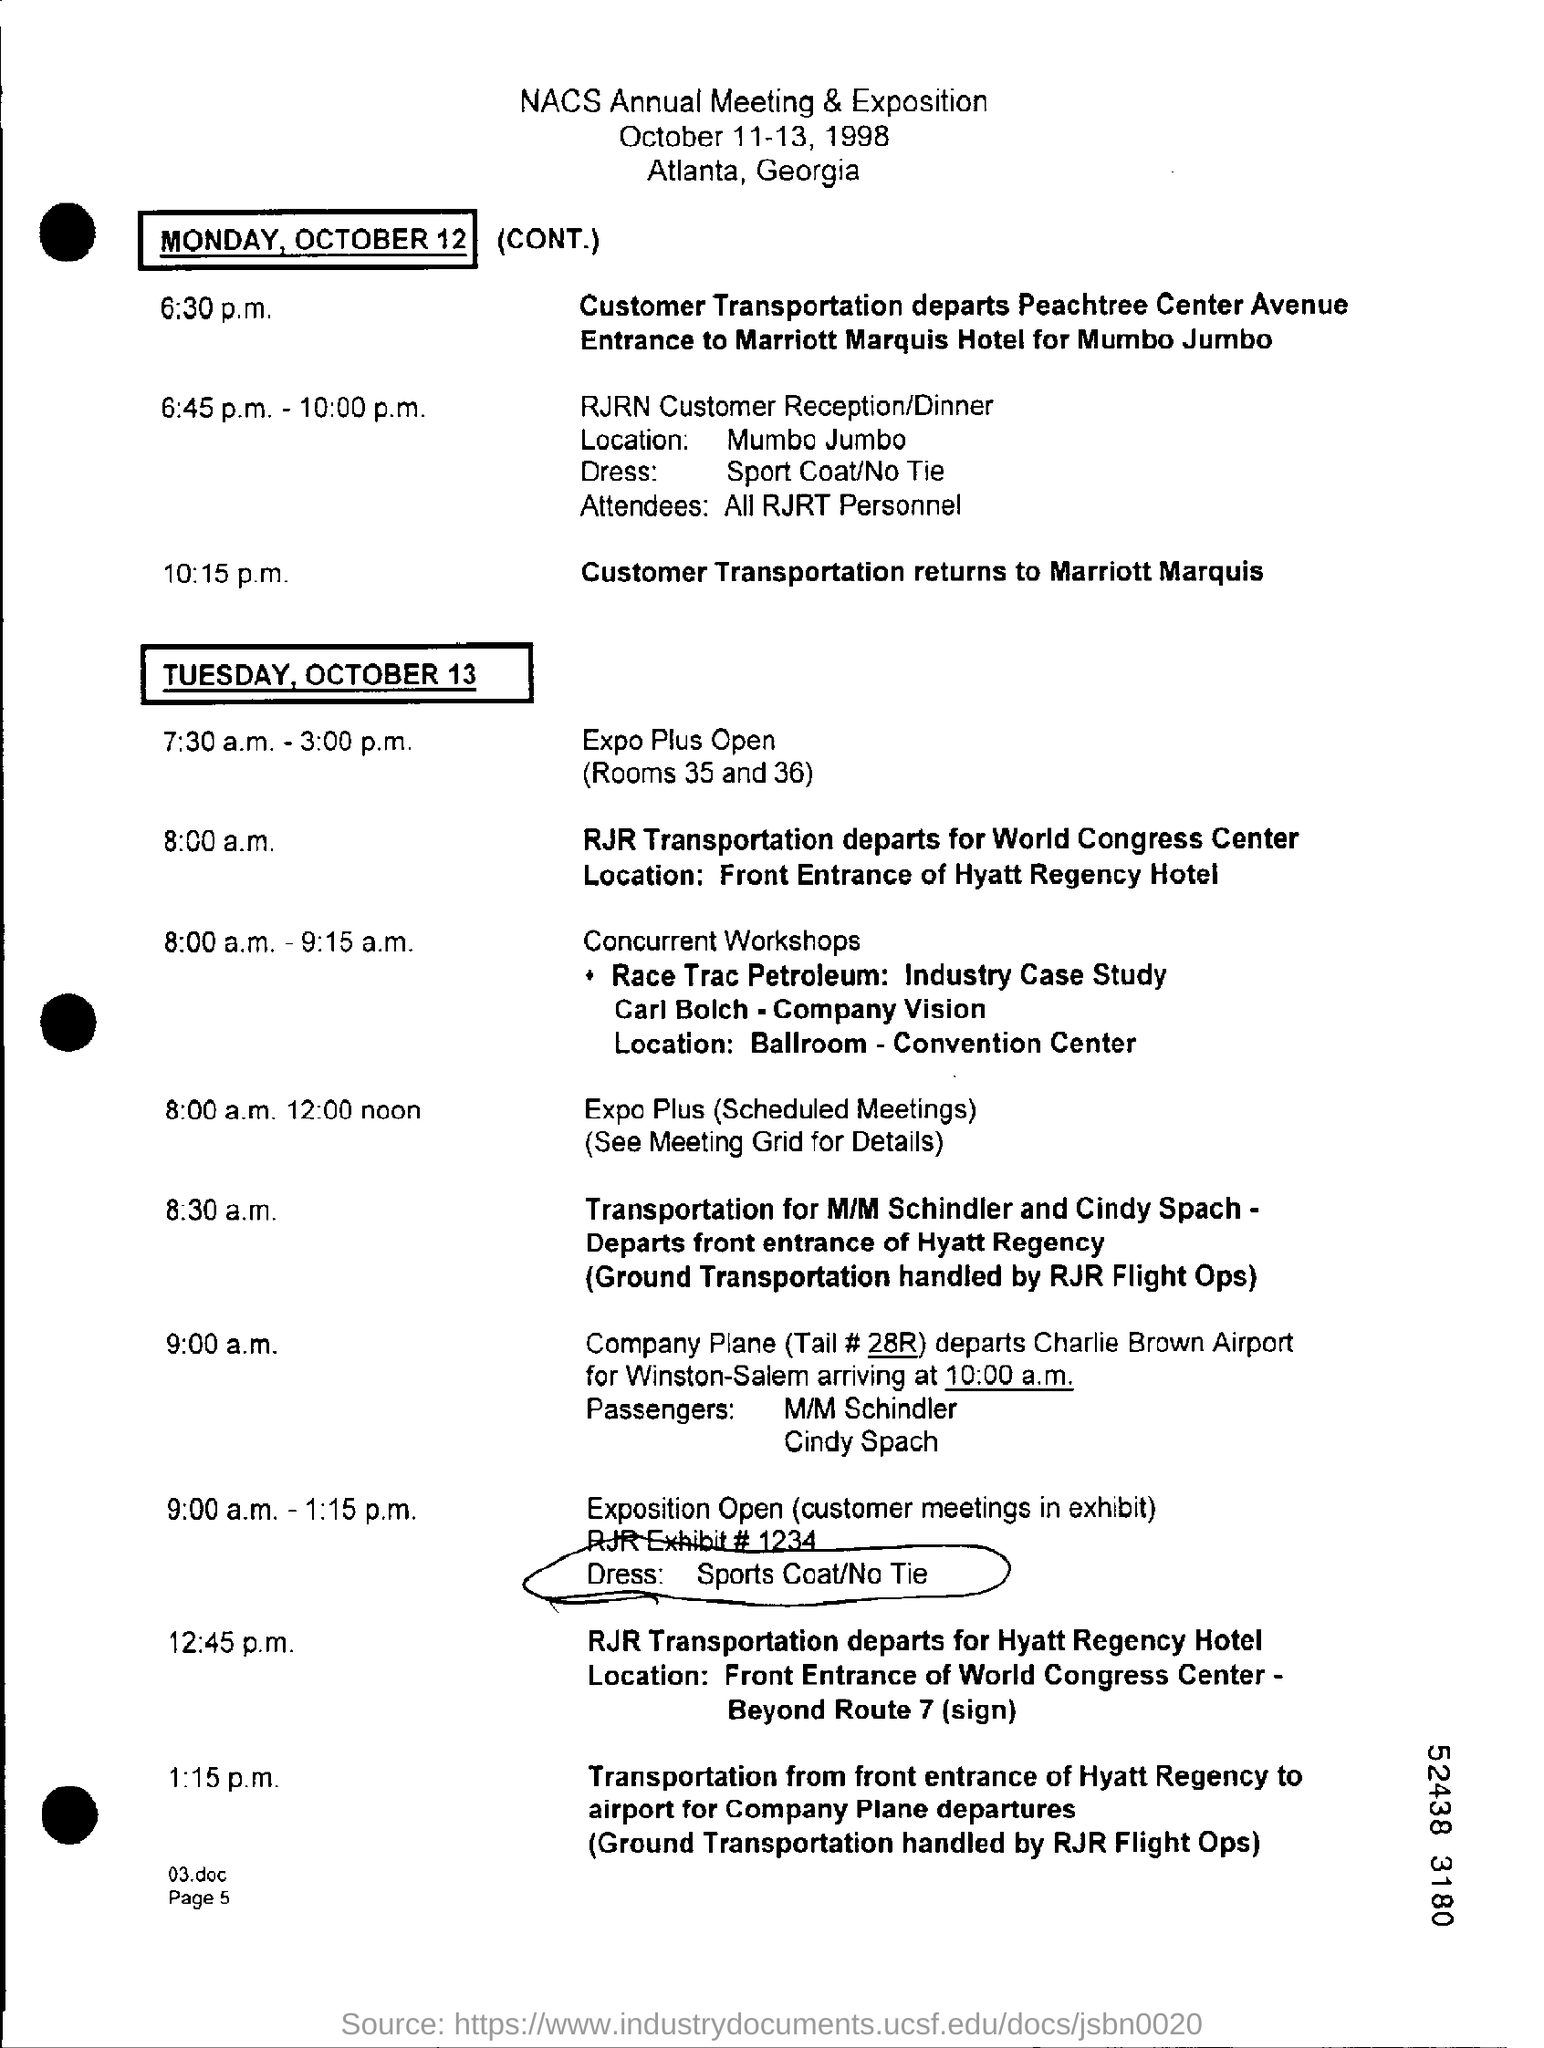Identify some key points in this picture. RJR Transportation will depart from the World Congress Center on Tuesday, October 13 at 8:00 a.m. The attendees at the meeting will consist of all RJRT personnel. The customer will return to the Marriott Marquis after their transportation. The NACS Annual Meeting & Exposition was scheduled to take place from October 11-13, 1998. The location of the RJRN Customer Reception/Dinner is Mumbo Jumbo. 